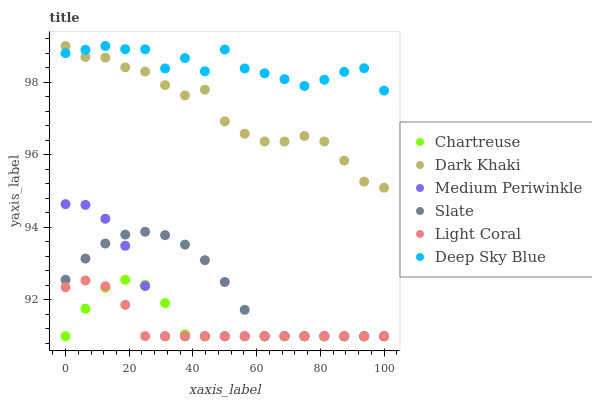Does Light Coral have the minimum area under the curve?
Answer yes or no. Yes. Does Deep Sky Blue have the maximum area under the curve?
Answer yes or no. Yes. Does Slate have the minimum area under the curve?
Answer yes or no. No. Does Slate have the maximum area under the curve?
Answer yes or no. No. Is Light Coral the smoothest?
Answer yes or no. Yes. Is Deep Sky Blue the roughest?
Answer yes or no. Yes. Is Slate the smoothest?
Answer yes or no. No. Is Slate the roughest?
Answer yes or no. No. Does Light Coral have the lowest value?
Answer yes or no. Yes. Does Dark Khaki have the lowest value?
Answer yes or no. No. Does Deep Sky Blue have the highest value?
Answer yes or no. Yes. Does Slate have the highest value?
Answer yes or no. No. Is Medium Periwinkle less than Dark Khaki?
Answer yes or no. Yes. Is Dark Khaki greater than Chartreuse?
Answer yes or no. Yes. Does Medium Periwinkle intersect Chartreuse?
Answer yes or no. Yes. Is Medium Periwinkle less than Chartreuse?
Answer yes or no. No. Is Medium Periwinkle greater than Chartreuse?
Answer yes or no. No. Does Medium Periwinkle intersect Dark Khaki?
Answer yes or no. No. 